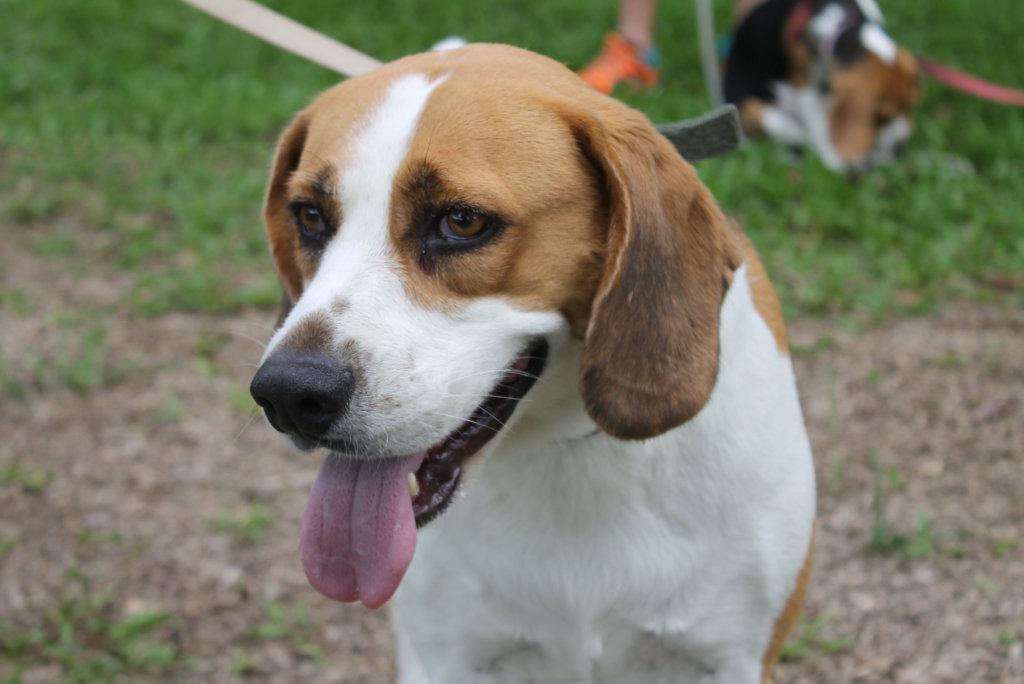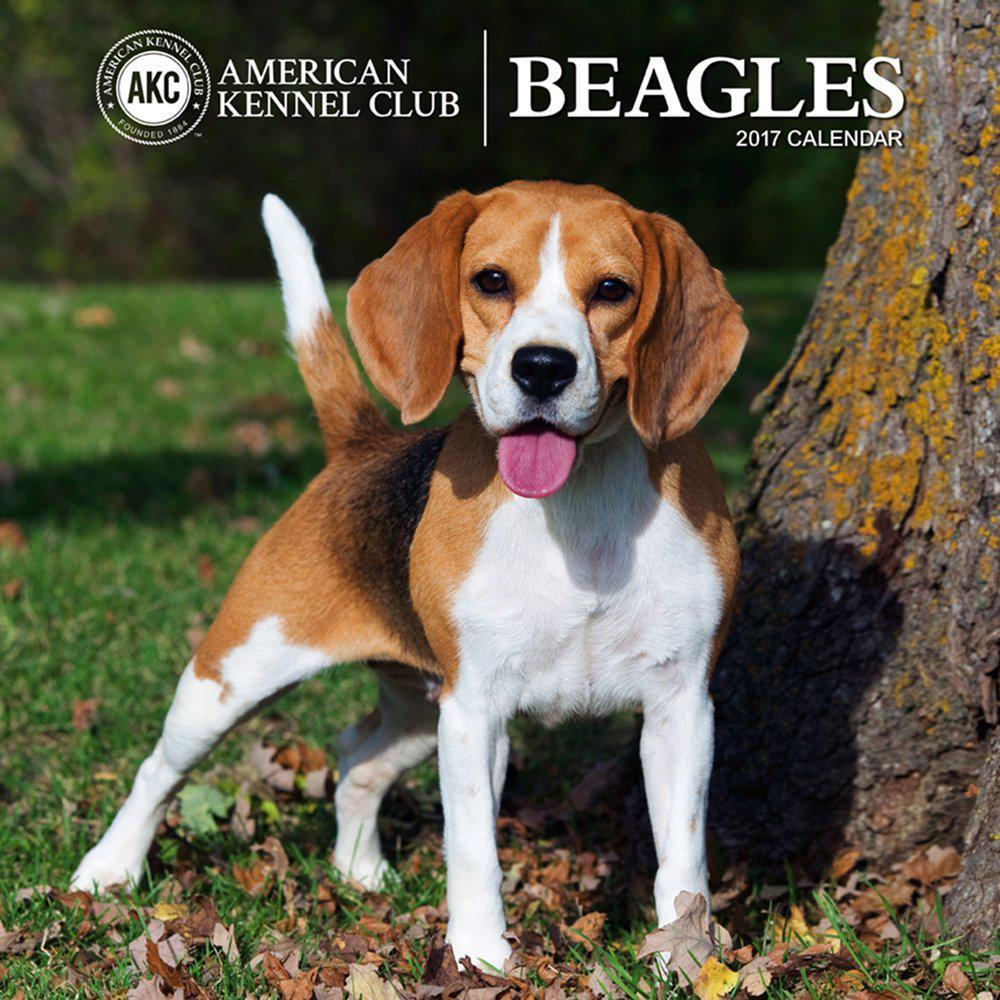The first image is the image on the left, the second image is the image on the right. Given the left and right images, does the statement "There are two dogs in the right image." hold true? Answer yes or no. No. The first image is the image on the left, the second image is the image on the right. Given the left and right images, does the statement "Flowers of some type are behind a dog in at least one image, and at least one image includes a beagle puppy." hold true? Answer yes or no. No. 